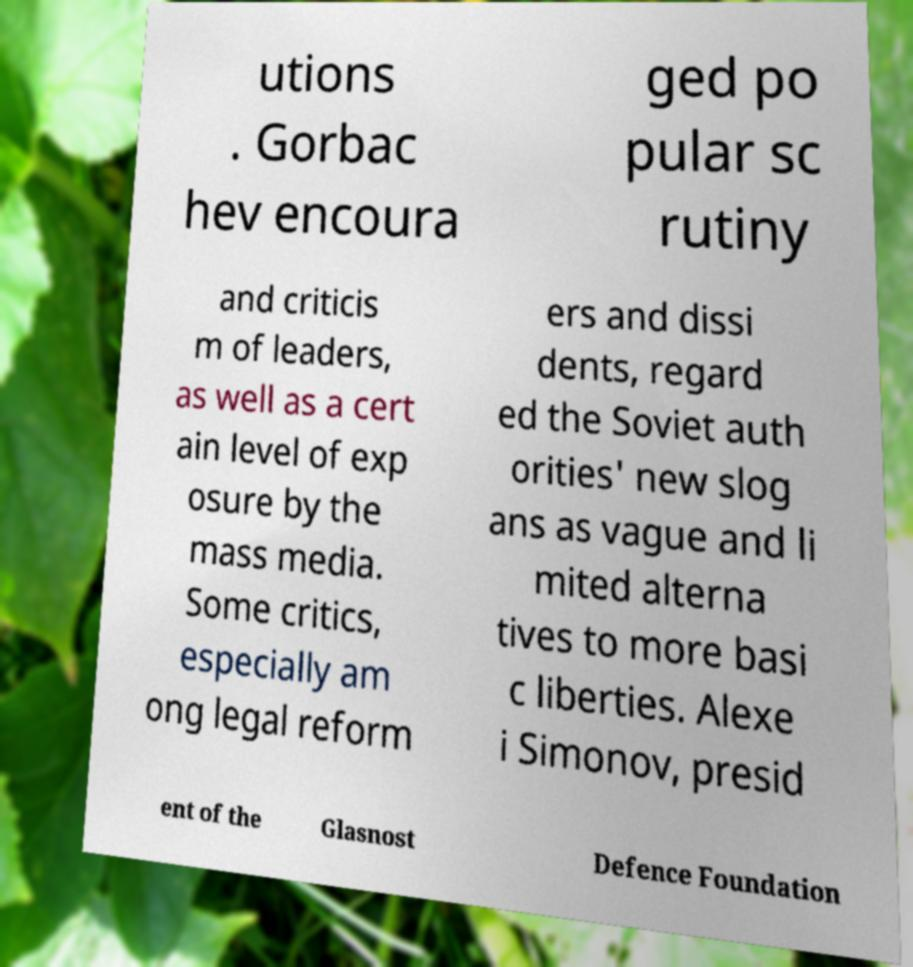Can you accurately transcribe the text from the provided image for me? utions . Gorbac hev encoura ged po pular sc rutiny and criticis m of leaders, as well as a cert ain level of exp osure by the mass media. Some critics, especially am ong legal reform ers and dissi dents, regard ed the Soviet auth orities' new slog ans as vague and li mited alterna tives to more basi c liberties. Alexe i Simonov, presid ent of the Glasnost Defence Foundation 